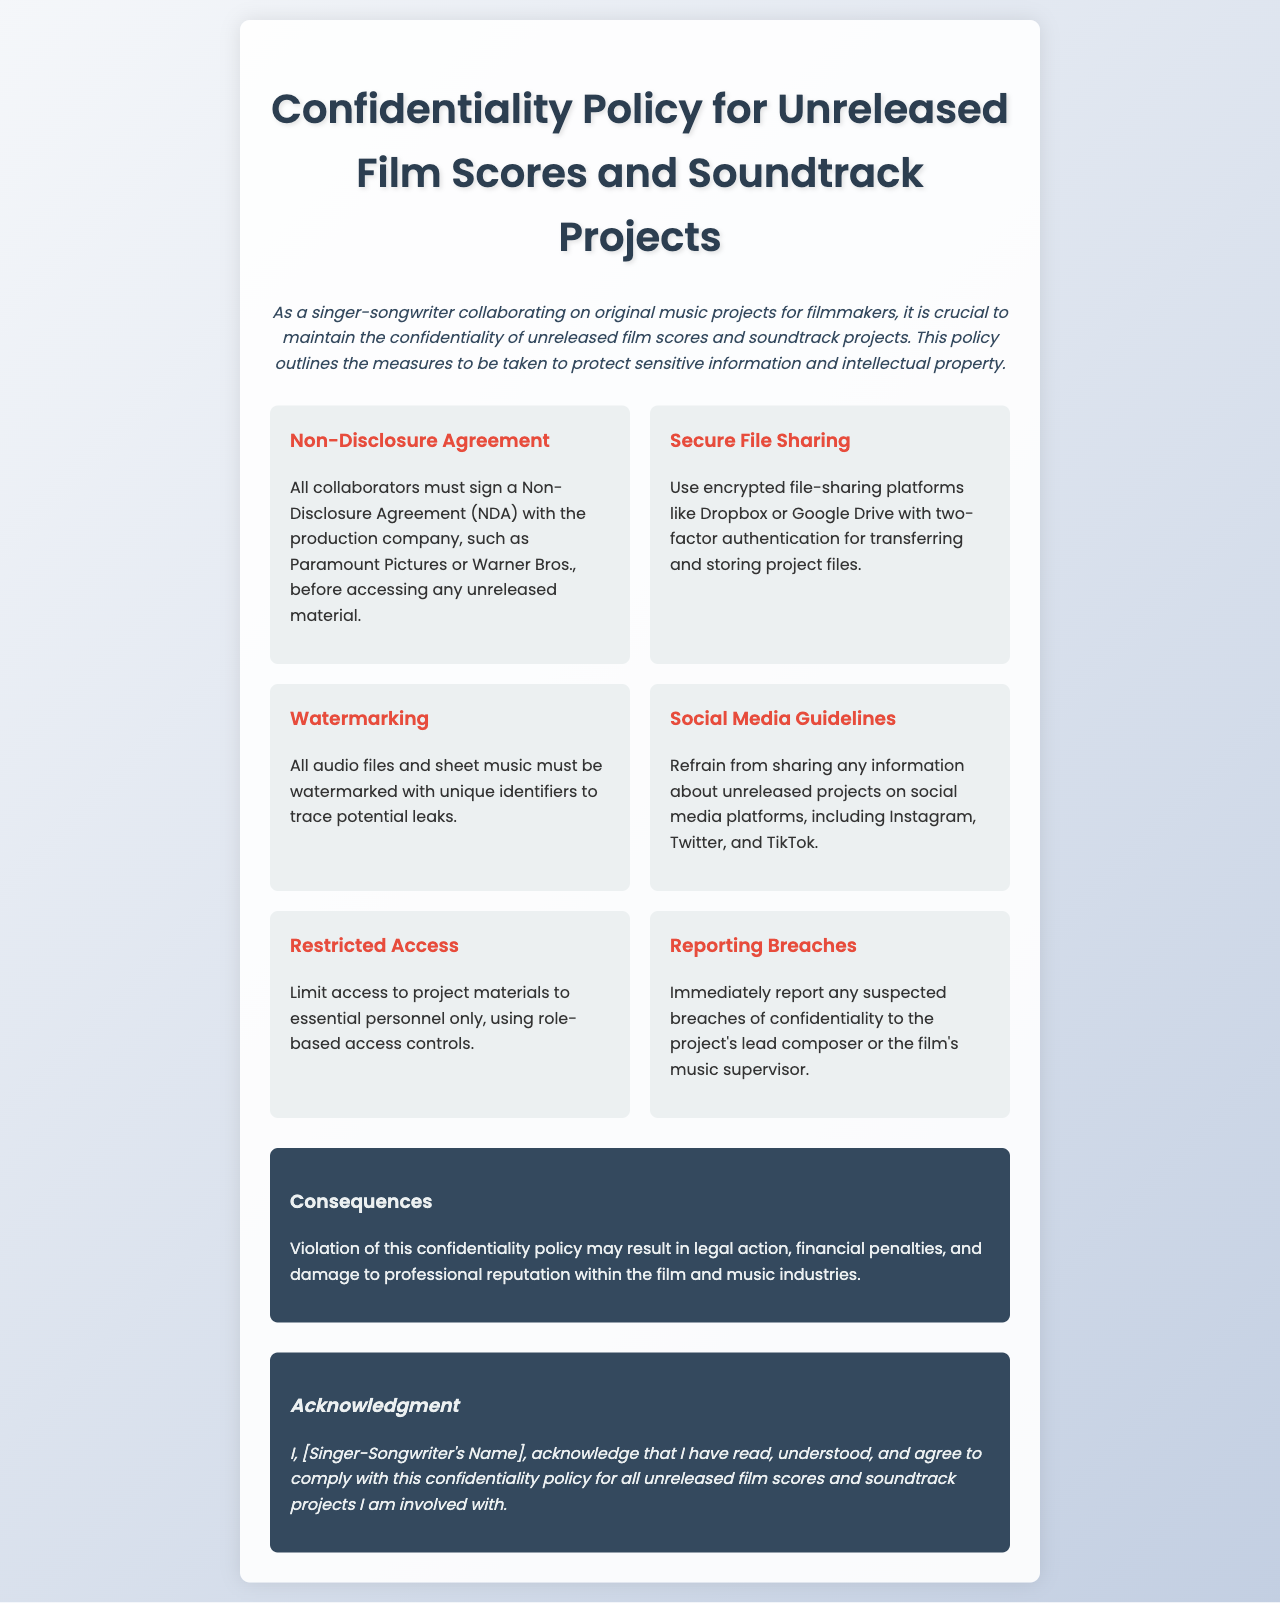what must collaborators sign before accessing unreleased material? Collaborators must sign a Non-Disclosure Agreement (NDA) with the production company.
Answer: Non-Disclosure Agreement (NDA) what platforms are recommended for secure file sharing? The document mentions using encrypted file-sharing platforms like Dropbox or Google Drive.
Answer: Dropbox or Google Drive what action should be taken if a confidentiality breach is suspected? Any suspected breaches of confidentiality must be reported immediately to the project's lead composer or the music supervisor.
Answer: Report immediately which guideline restricts sharing information on social media? The document states to refrain from sharing any information about unreleased projects on social media.
Answer: Social Media Guidelines what happens if the confidentiality policy is violated? Violation of the confidentiality policy may result in legal action, financial penalties, and damage to professional reputation.
Answer: Legal action how should access to project materials be limited? Access to project materials should be limited to essential personnel only, using role-based access controls.
Answer: Essential personnel only what identifier is required on audio files and sheet music? All audio files and sheet music must be watermarked with unique identifiers.
Answer: Watermarking who must acknowledge understanding of the policy? The singer-songwriter must acknowledge that they have read, understood, and agree to comply with the policy.
Answer: Singer-Songwriter 